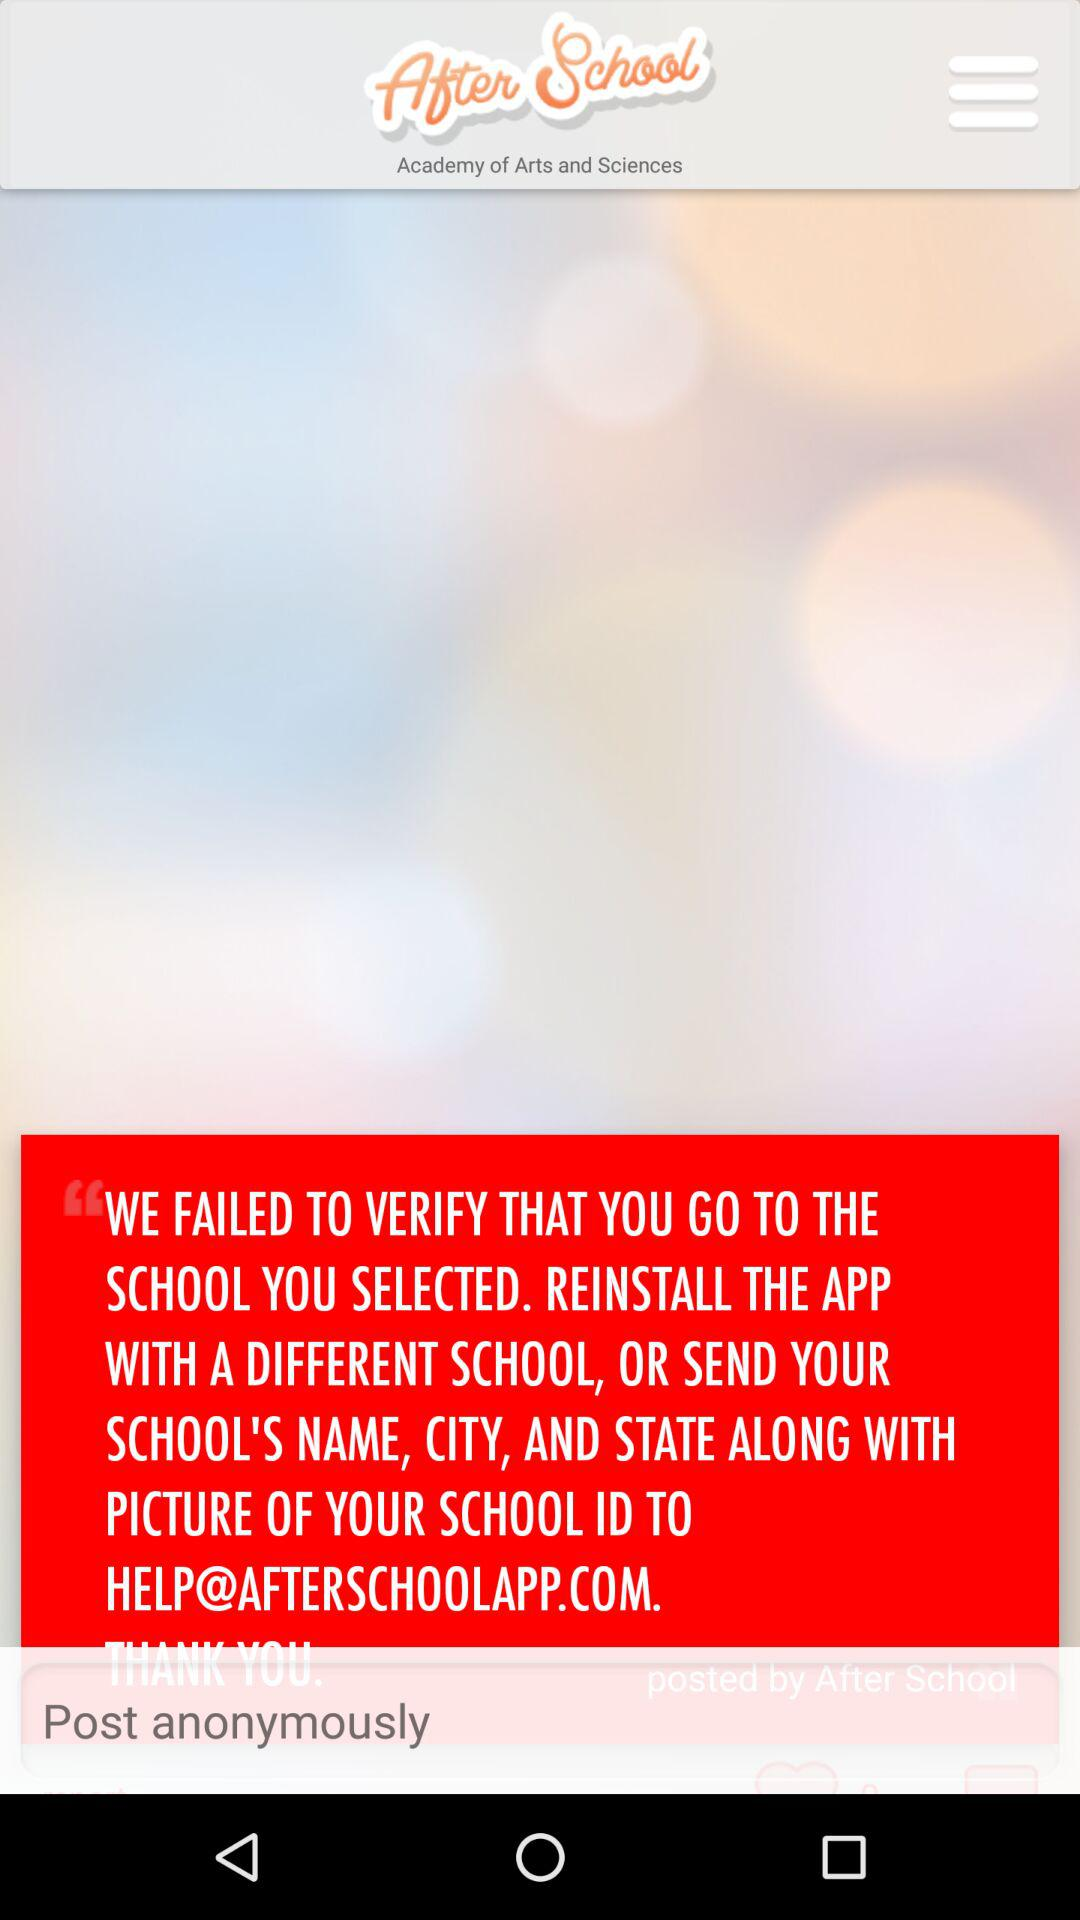What is the name of the application? The name of the application is "After School". 